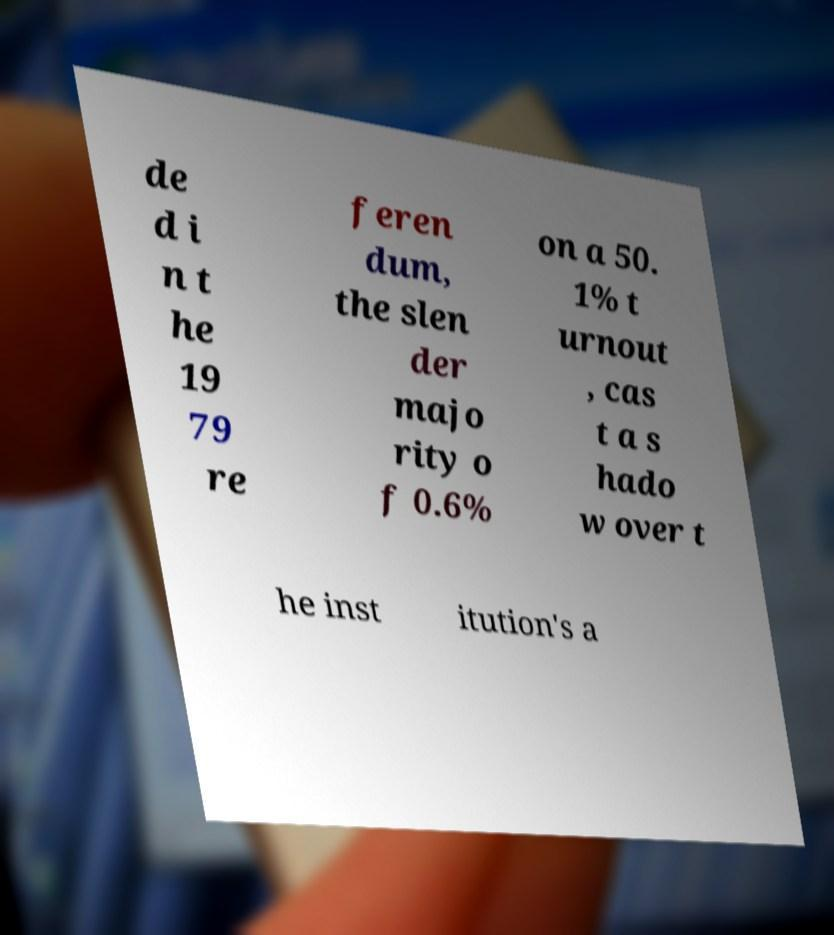Could you assist in decoding the text presented in this image and type it out clearly? de d i n t he 19 79 re feren dum, the slen der majo rity o f 0.6% on a 50. 1% t urnout , cas t a s hado w over t he inst itution's a 